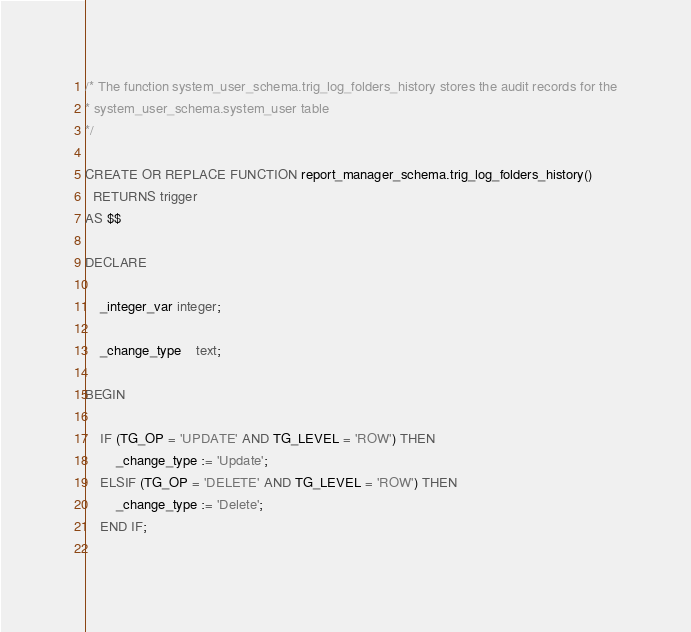Convert code to text. <code><loc_0><loc_0><loc_500><loc_500><_SQL_>/* The function system_user_schema.trig_log_folders_history stores the audit records for the
* system_user_schema.system_user table
*/

CREATE OR REPLACE FUNCTION report_manager_schema.trig_log_folders_history()
  RETURNS trigger
AS $$

DECLARE
		
	_integer_var integer;
	
	_change_type	text;
	
BEGIN

	IF (TG_OP = 'UPDATE' AND TG_LEVEL = 'ROW') THEN
		_change_type := 'Update';
	ELSIF (TG_OP = 'DELETE' AND TG_LEVEL = 'ROW') THEN
		_change_type := 'Delete';
	END IF;
	</code> 